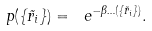Convert formula to latex. <formula><loc_0><loc_0><loc_500><loc_500>p ( \{ \vec { r } _ { i } \} ) = \ e ^ { - \beta \Phi ( \{ \vec { r } _ { i } \} ) } .</formula> 